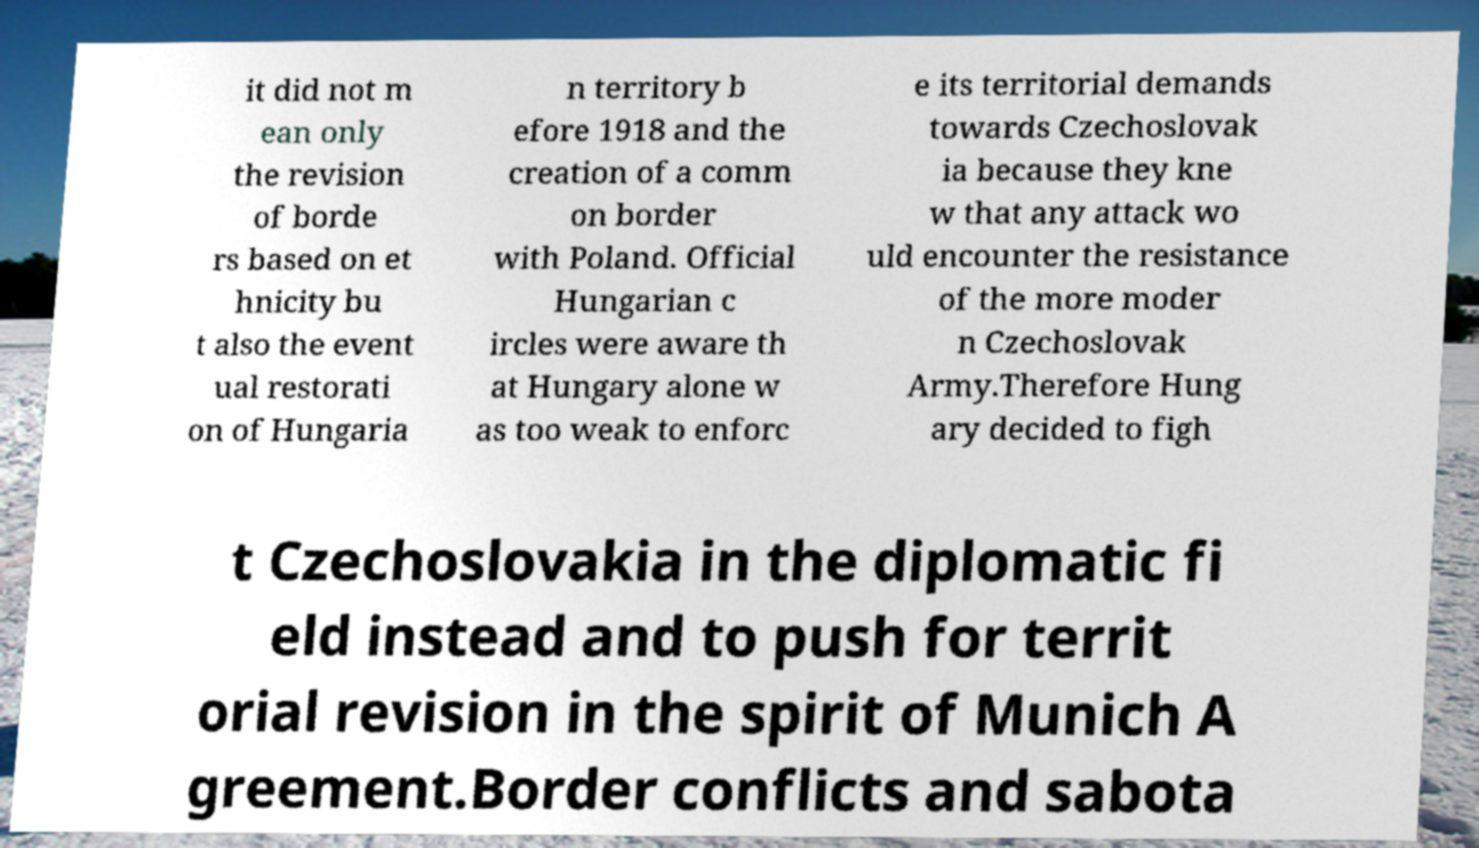Please read and relay the text visible in this image. What does it say? it did not m ean only the revision of borde rs based on et hnicity bu t also the event ual restorati on of Hungaria n territory b efore 1918 and the creation of a comm on border with Poland. Official Hungarian c ircles were aware th at Hungary alone w as too weak to enforc e its territorial demands towards Czechoslovak ia because they kne w that any attack wo uld encounter the resistance of the more moder n Czechoslovak Army.Therefore Hung ary decided to figh t Czechoslovakia in the diplomatic fi eld instead and to push for territ orial revision in the spirit of Munich A greement.Border conflicts and sabota 